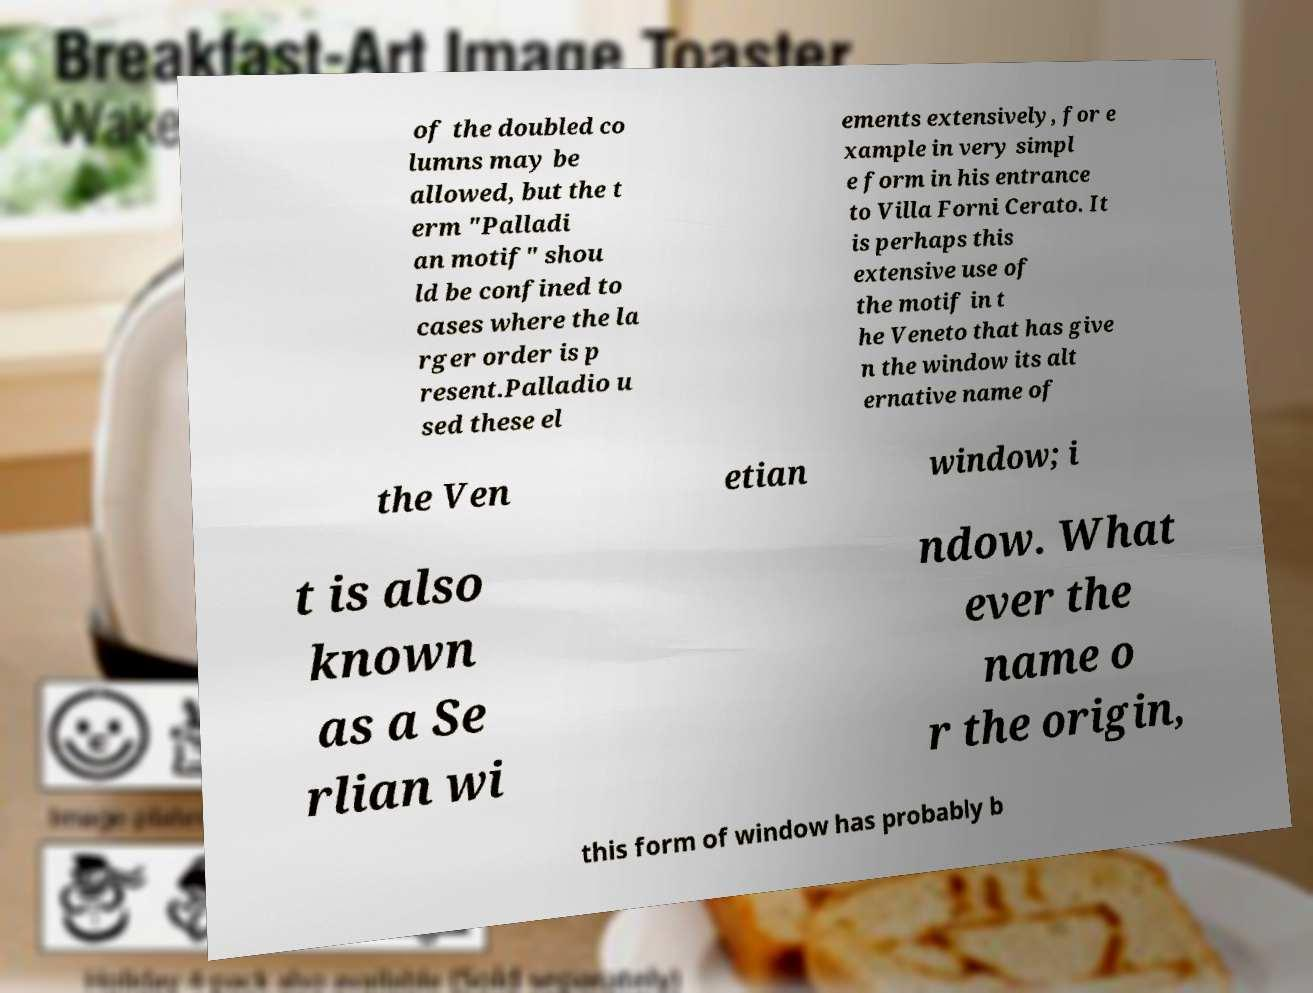Could you extract and type out the text from this image? of the doubled co lumns may be allowed, but the t erm "Palladi an motif" shou ld be confined to cases where the la rger order is p resent.Palladio u sed these el ements extensively, for e xample in very simpl e form in his entrance to Villa Forni Cerato. It is perhaps this extensive use of the motif in t he Veneto that has give n the window its alt ernative name of the Ven etian window; i t is also known as a Se rlian wi ndow. What ever the name o r the origin, this form of window has probably b 